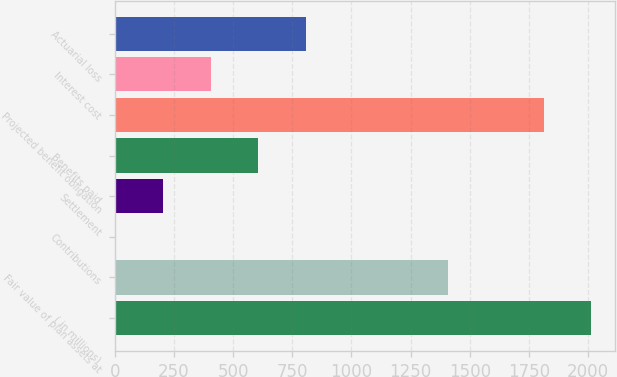<chart> <loc_0><loc_0><loc_500><loc_500><bar_chart><fcel>( in millions)<fcel>Fair value of plan assets at<fcel>Contributions<fcel>Settlement<fcel>Benefits paid<fcel>Projected benefit obligation<fcel>Interest cost<fcel>Actuarial loss<nl><fcel>2012<fcel>1409.6<fcel>4<fcel>204.8<fcel>606.4<fcel>1811.2<fcel>405.6<fcel>807.2<nl></chart> 